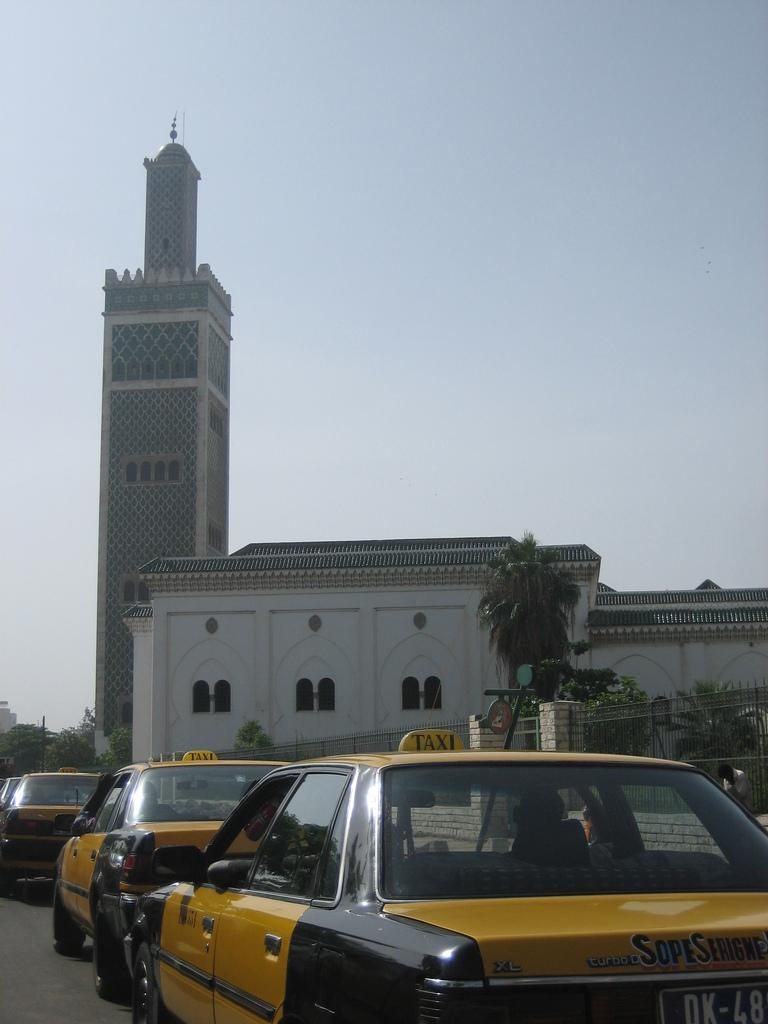Can you describe this image briefly? In this picture we can see cars on the road, building with windows, trees and a person and in the background we can see the sky. 